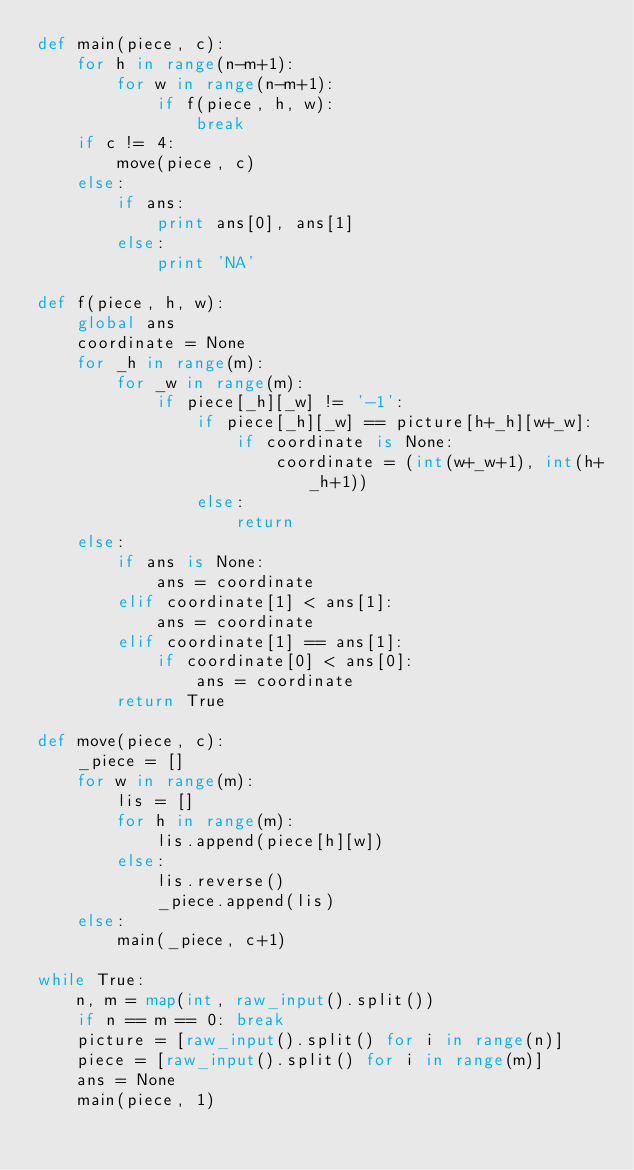<code> <loc_0><loc_0><loc_500><loc_500><_Python_>def main(piece, c):
    for h in range(n-m+1):
        for w in range(n-m+1):
            if f(piece, h, w):
                break
    if c != 4:
        move(piece, c)
    else:
        if ans:
            print ans[0], ans[1]
        else:
            print 'NA'

def f(piece, h, w):
    global ans
    coordinate = None
    for _h in range(m):
        for _w in range(m):
            if piece[_h][_w] != '-1':
                if piece[_h][_w] == picture[h+_h][w+_w]:
                    if coordinate is None:
                        coordinate = (int(w+_w+1), int(h+_h+1))
                else:
                    return
    else:
        if ans is None:
            ans = coordinate
        elif coordinate[1] < ans[1]:
            ans = coordinate
        elif coordinate[1] == ans[1]:
            if coordinate[0] < ans[0]:
                ans = coordinate
        return True
    
def move(piece, c):
    _piece = []
    for w in range(m):
        lis = []
        for h in range(m):
            lis.append(piece[h][w])
        else:
            lis.reverse()
            _piece.append(lis)
    else:
        main(_piece, c+1)

while True:
    n, m = map(int, raw_input().split())
    if n == m == 0: break
    picture = [raw_input().split() for i in range(n)]
    piece = [raw_input().split() for i in range(m)]
    ans = None
    main(piece, 1)</code> 